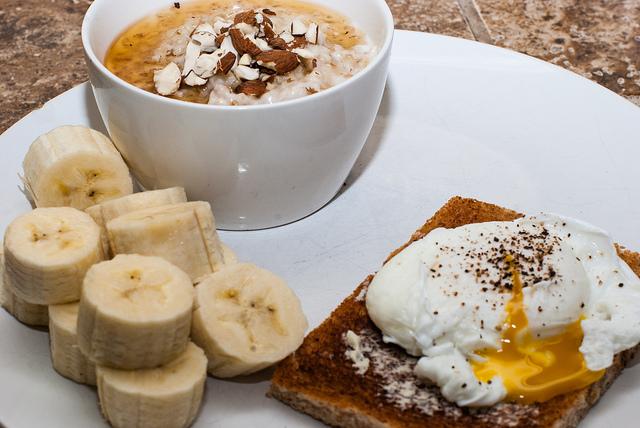What meal are these foods suited for?
Concise answer only. Breakfast. What type of fruit is displayed?
Give a very brief answer. Banana. What's in the small bowl?
Keep it brief. Creme brulee. 